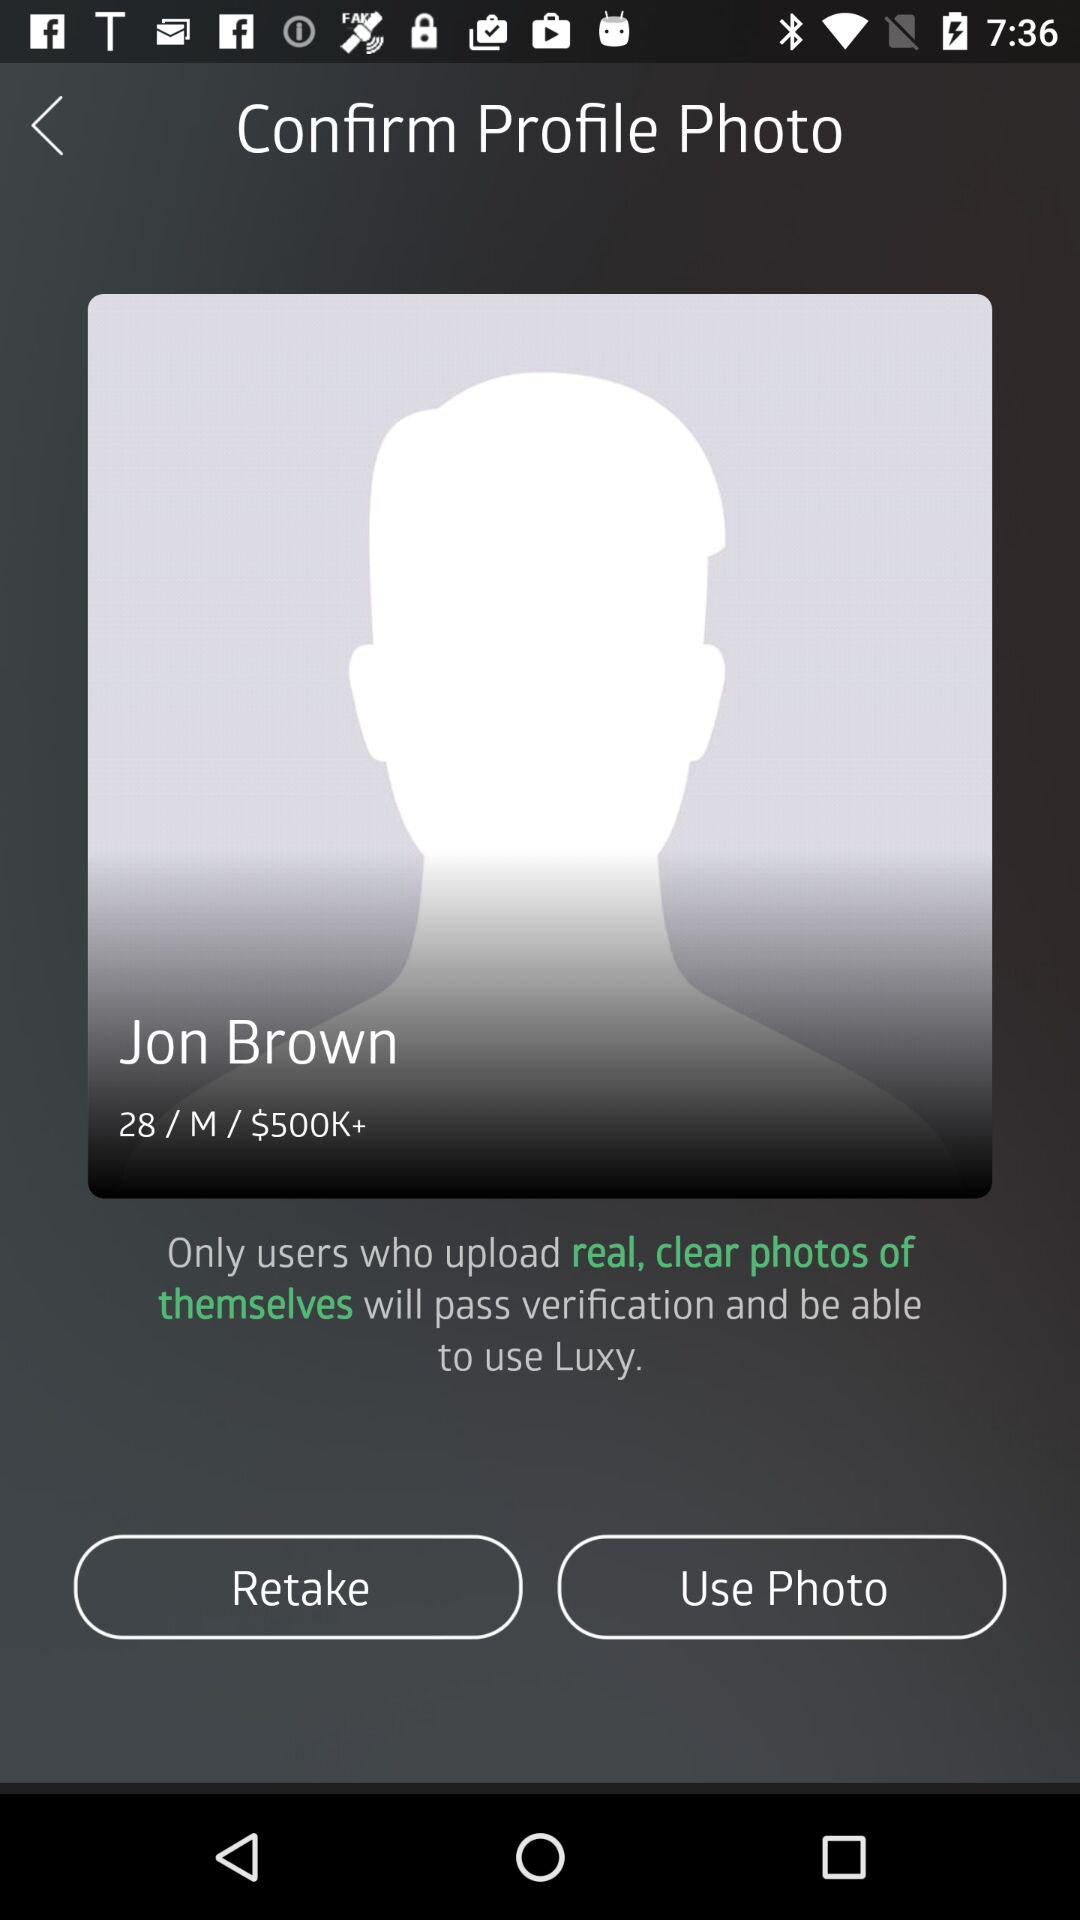What is the price mentioned in the profile? The mentioned price is $500K+. 